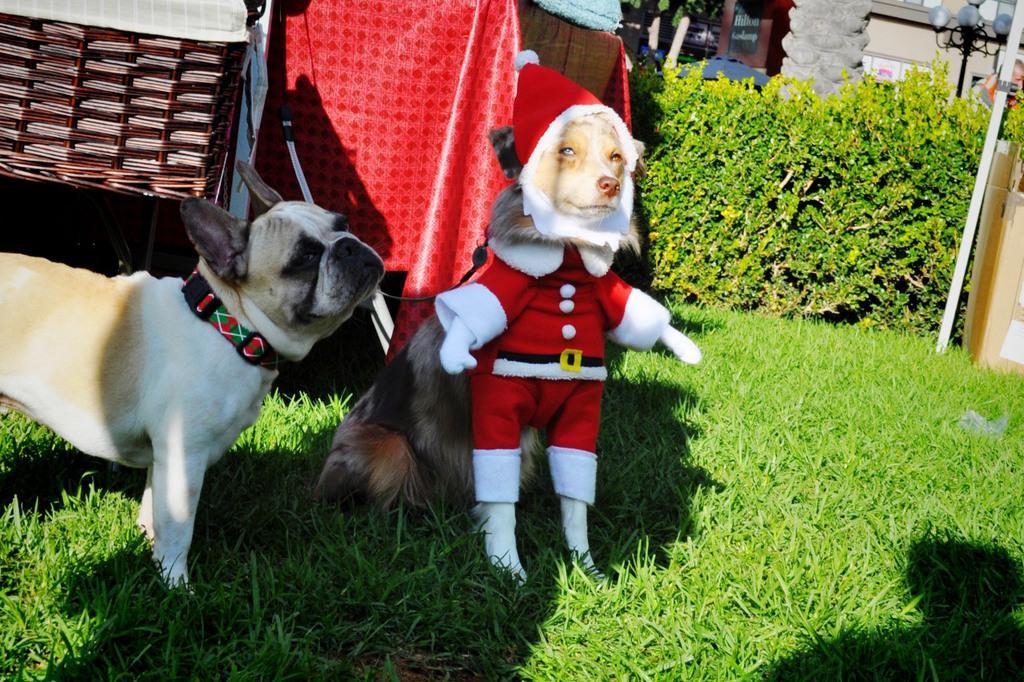Describe this image in one or two sentences. In this image, I can see two dogs. One dog is wearing fancy dress and sitting and the other dog is standing. This is the grass. These are the bushes. This looks like a table with the cloth. I think this is a pillar. Here is a pole. On the right side of the image, that looks like a cardboard box. In the background, I can see the light pole and a person. 